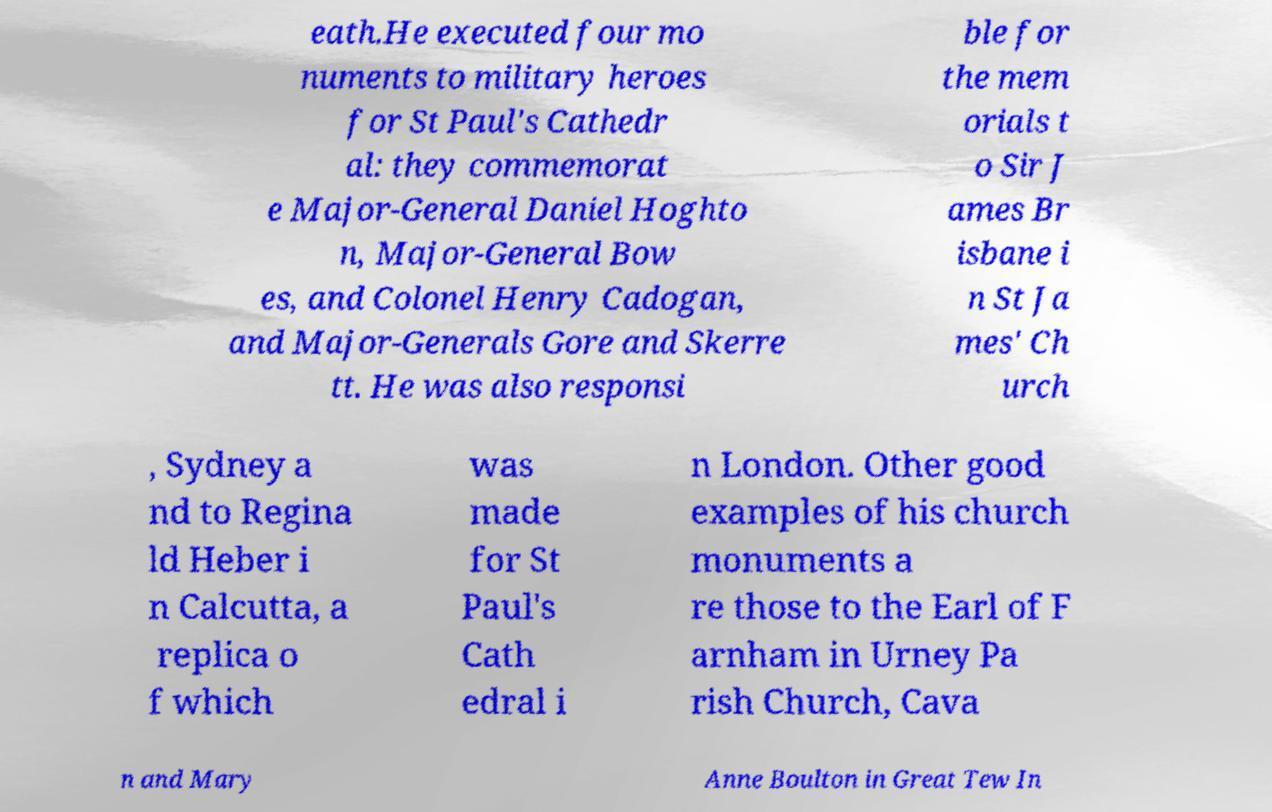There's text embedded in this image that I need extracted. Can you transcribe it verbatim? eath.He executed four mo numents to military heroes for St Paul's Cathedr al: they commemorat e Major-General Daniel Hoghto n, Major-General Bow es, and Colonel Henry Cadogan, and Major-Generals Gore and Skerre tt. He was also responsi ble for the mem orials t o Sir J ames Br isbane i n St Ja mes' Ch urch , Sydney a nd to Regina ld Heber i n Calcutta, a replica o f which was made for St Paul's Cath edral i n London. Other good examples of his church monuments a re those to the Earl of F arnham in Urney Pa rish Church, Cava n and Mary Anne Boulton in Great Tew In 